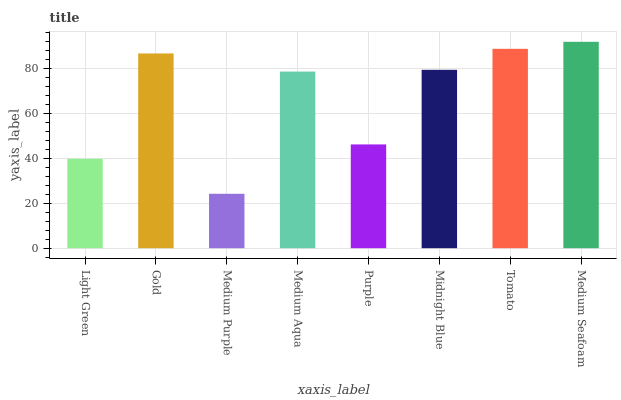Is Medium Purple the minimum?
Answer yes or no. Yes. Is Medium Seafoam the maximum?
Answer yes or no. Yes. Is Gold the minimum?
Answer yes or no. No. Is Gold the maximum?
Answer yes or no. No. Is Gold greater than Light Green?
Answer yes or no. Yes. Is Light Green less than Gold?
Answer yes or no. Yes. Is Light Green greater than Gold?
Answer yes or no. No. Is Gold less than Light Green?
Answer yes or no. No. Is Midnight Blue the high median?
Answer yes or no. Yes. Is Medium Aqua the low median?
Answer yes or no. Yes. Is Medium Aqua the high median?
Answer yes or no. No. Is Light Green the low median?
Answer yes or no. No. 